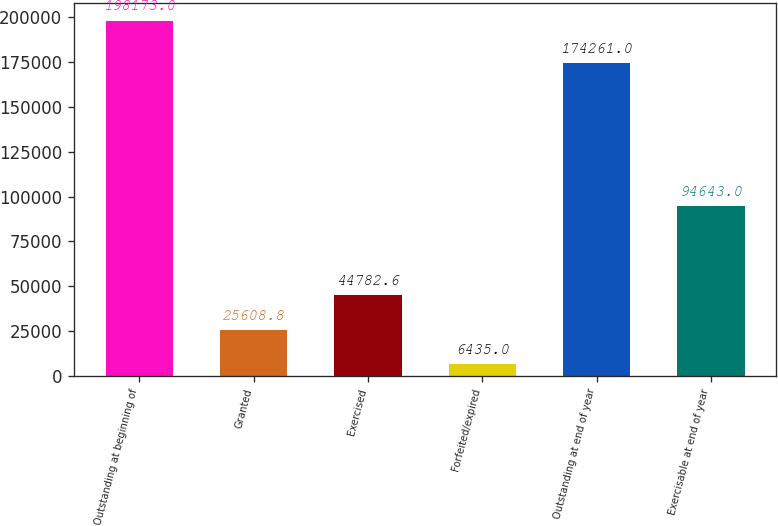<chart> <loc_0><loc_0><loc_500><loc_500><bar_chart><fcel>Outstanding at beginning of<fcel>Granted<fcel>Exercised<fcel>Forfeited/expired<fcel>Outstanding at end of year<fcel>Exercisable at end of year<nl><fcel>198173<fcel>25608.8<fcel>44782.6<fcel>6435<fcel>174261<fcel>94643<nl></chart> 